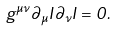<formula> <loc_0><loc_0><loc_500><loc_500>g ^ { \mu \nu } \partial _ { \mu } I \partial _ { \nu } I = 0 .</formula> 